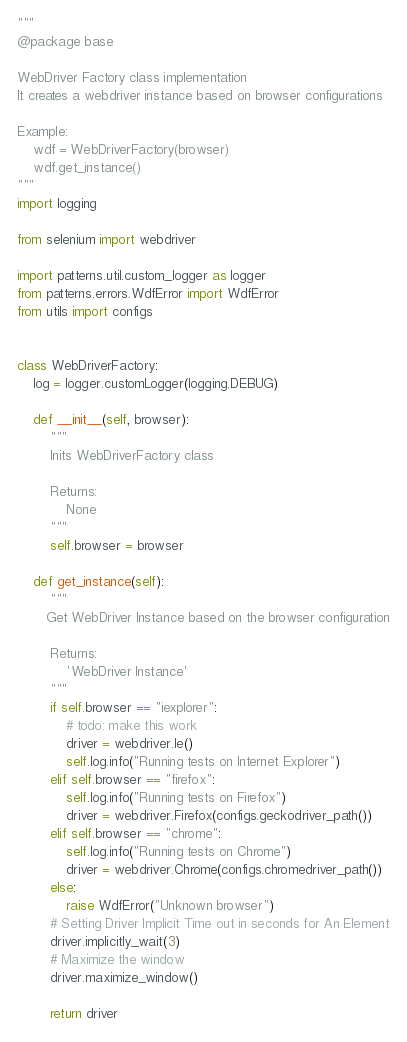Convert code to text. <code><loc_0><loc_0><loc_500><loc_500><_Python_>"""
@package base

WebDriver Factory class implementation
It creates a webdriver instance based on browser configurations

Example:
    wdf = WebDriverFactory(browser)
    wdf.get_instance()
"""
import logging

from selenium import webdriver

import patterns.util.custom_logger as logger
from patterns.errors.WdfError import WdfError
from utils import configs


class WebDriverFactory:
    log = logger.customLogger(logging.DEBUG)

    def __init__(self, browser):
        """
        Inits WebDriverFactory class

        Returns:
            None
        """
        self.browser = browser

    def get_instance(self):
        """
       Get WebDriver Instance based on the browser configuration

        Returns:
            'WebDriver Instance'
        """
        if self.browser == "iexplorer":
            # todo: make this work
            driver = webdriver.Ie()
            self.log.info("Running tests on Internet Explorer")
        elif self.browser == "firefox":
            self.log.info("Running tests on Firefox")
            driver = webdriver.Firefox(configs.geckodriver_path())
        elif self.browser == "chrome":
            self.log.info("Running tests on Chrome")
            driver = webdriver.Chrome(configs.chromedriver_path())
        else:
            raise WdfError("Unknown browser")
        # Setting Driver Implicit Time out in seconds for An Element
        driver.implicitly_wait(3)
        # Maximize the window
        driver.maximize_window()

        return driver
</code> 